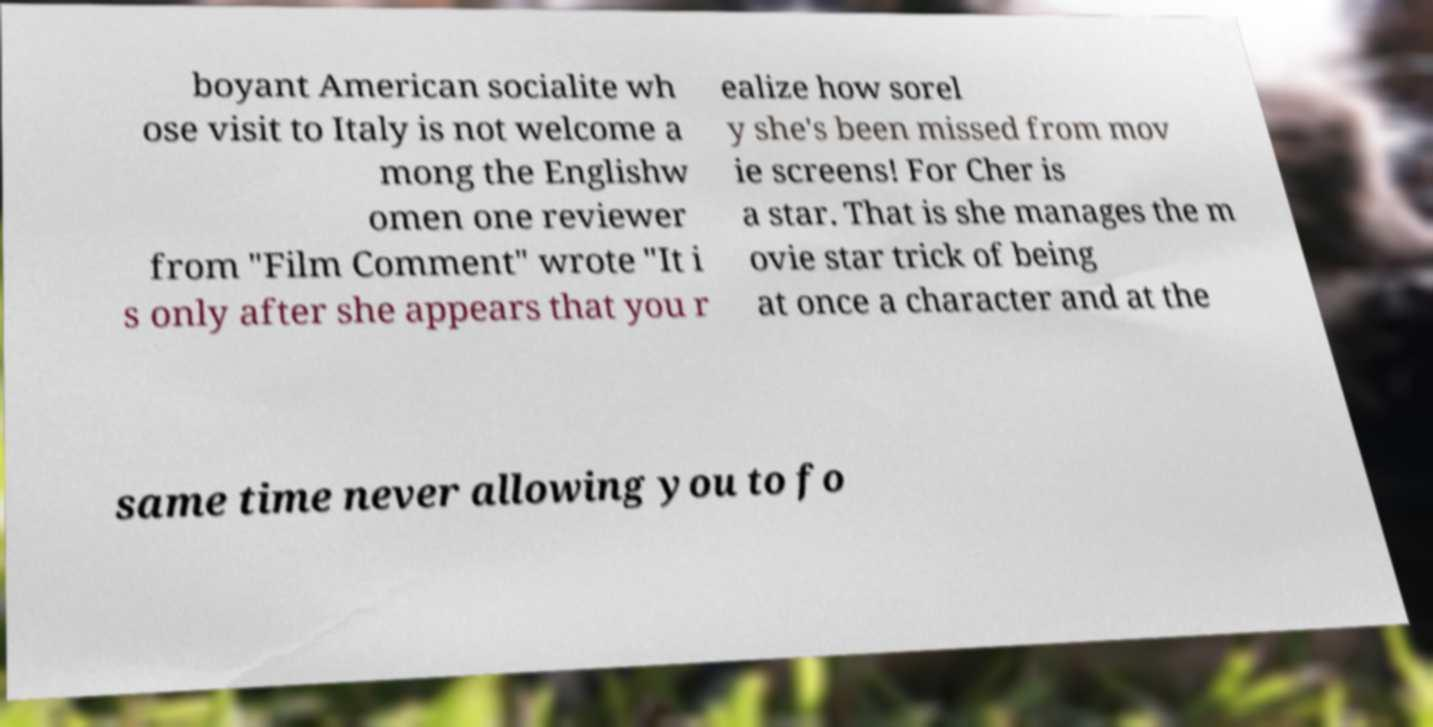There's text embedded in this image that I need extracted. Can you transcribe it verbatim? boyant American socialite wh ose visit to Italy is not welcome a mong the Englishw omen one reviewer from "Film Comment" wrote "It i s only after she appears that you r ealize how sorel y she's been missed from mov ie screens! For Cher is a star. That is she manages the m ovie star trick of being at once a character and at the same time never allowing you to fo 